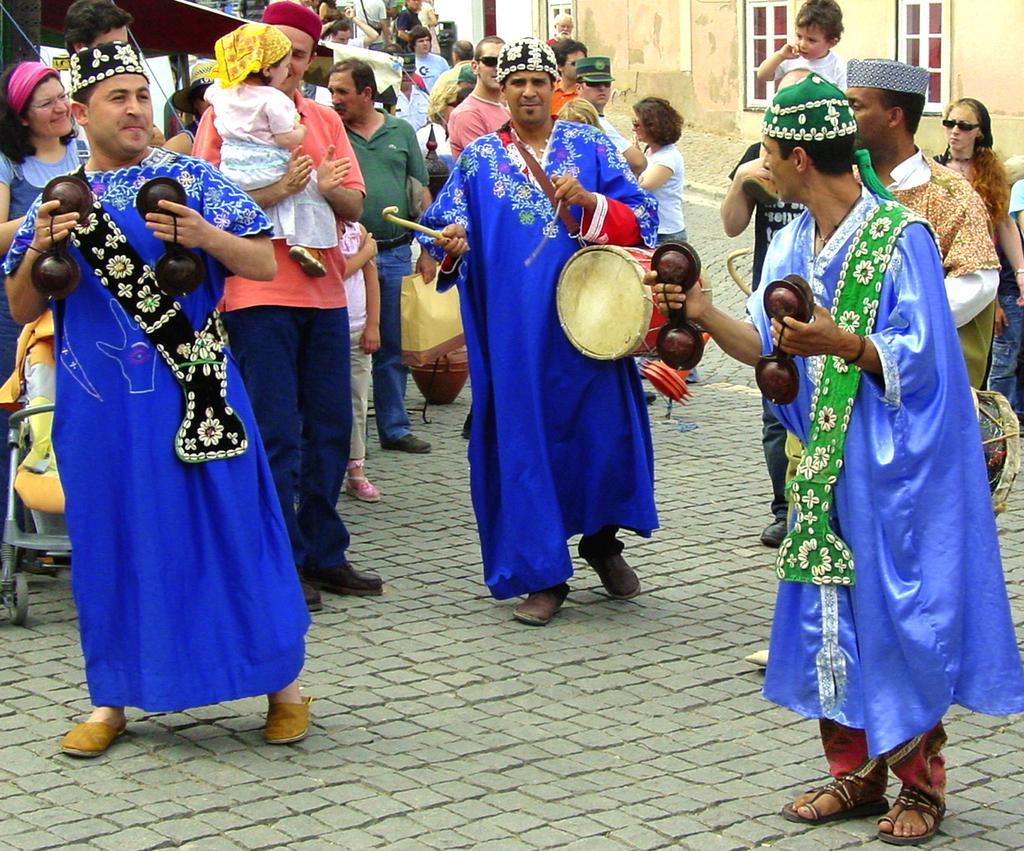Please provide a concise description of this image. In this image there are group of people standing on the road. The persons with blue dress are playing musical instrument. At the back there is a building and the left there is a person holding a baby traveler. 